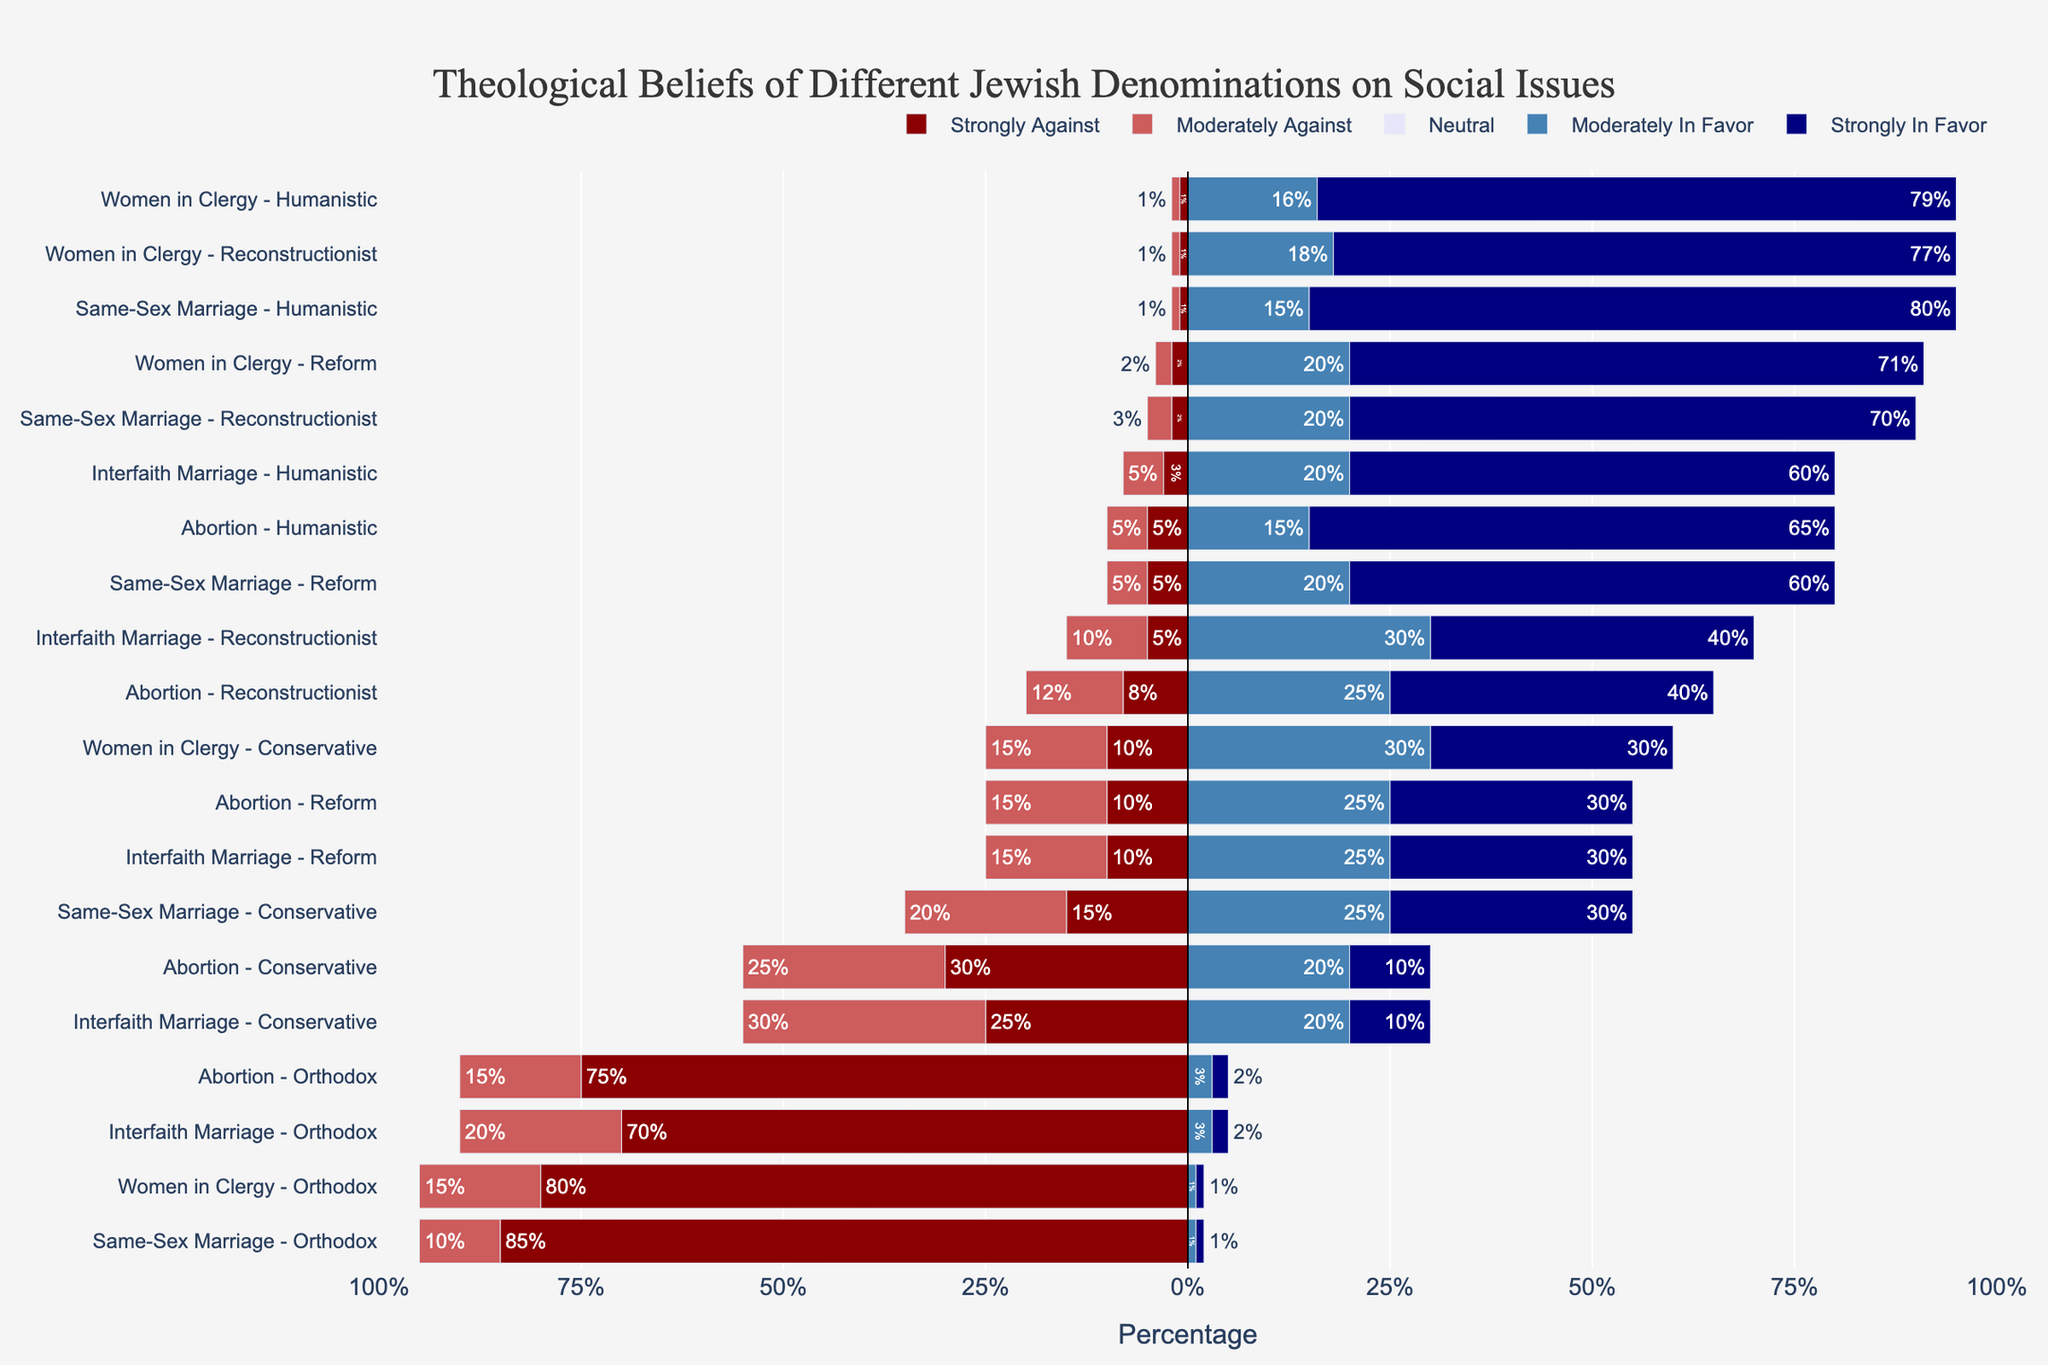What's the strongest opposition against same-sex marriage? Look at the bars representing "Strongly Against" for same-sex marriage in each denomination. The Orthodox denomination has the largest bar in the "Strongly Against" category, standing at 85%.
Answer: 85% Which denomination has the highest percentage of people strongly in favor of same-sex marriage? Identify the "Strongly In Favor" bar for same-sex marriage. The Humanistic denomination has the longest bar in this category, reaching 80%.
Answer: Humanistic Compare the support for women in clergy between the Orthodox and Reform denominations. Which one has a higher percentage of strong support? Compare the "Strongly In Favor" percentages for women in clergy in the Orthodox and Reform denominations. The Reform group shows 71% strongly in favor, while Orthodox shows only 1%.
Answer: Reform What is the combined percentage of Orthodox Jews who are against interfaith marriage (both strongly and moderately)? Add the percentages for "Strongly Against" and "Moderately Against" in the Orthodox denomination for interfaith marriage. That's 70% + 20% = 90%.
Answer: 90% Which social issue shows the highest overall percentage of strong support among Humanistic Jews? Look at the "Strongly In Favor" bars for each social issue among Humanistic Jews. Same-sex marriage has the highest bar, which is 80%.
Answer: Same-sex marriage How does the neutral opinion about abortion compare between the Conservative and Reform denominations? Compare the bars for "Neutral" on abortion between Conservative (15%) and Reform (20%) denominations. Reform has a higher percentage by 5%.
Answer: Reform by 5% What is the difference in strong opposition to abortion between the Orthodox and Humanistic denominations? Subtract the percentage of "Strongly Against" in Humanistic (5%) from Orthodox (75%). The difference is 70%.
Answer: 70% What percentage of Conservative Jews are in favor (moderately and strongly combined) of women in the clergy? Add "Moderately In Favor" and "Strongly In Favor" percentages for Conservative Jews on women in clergy: 30% + 30% = 60%.
Answer: 60% Between the Reform and Reconstructionist denominations, which has a higher percentage of neutrality on interfaith marriage? Compare the "Neutral" bars for interfaith marriage between Reform (20%) and Reconstructionist (15%). Reform has a higher percentage.
Answer: Reform Considering the Orthodox denomination, which social issue has the highest percentage of strong support? Among the bars representing "Strongly In Favor" for all social issues in the Orthodox denomination, none exceed 2%, making same-sex marriage the highest at 2%.
Answer: Same-sex marriage 